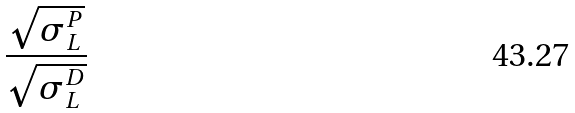<formula> <loc_0><loc_0><loc_500><loc_500>\frac { \sqrt { \sigma _ { L } ^ { P } } } { \sqrt { \sigma _ { L } ^ { D } } }</formula> 